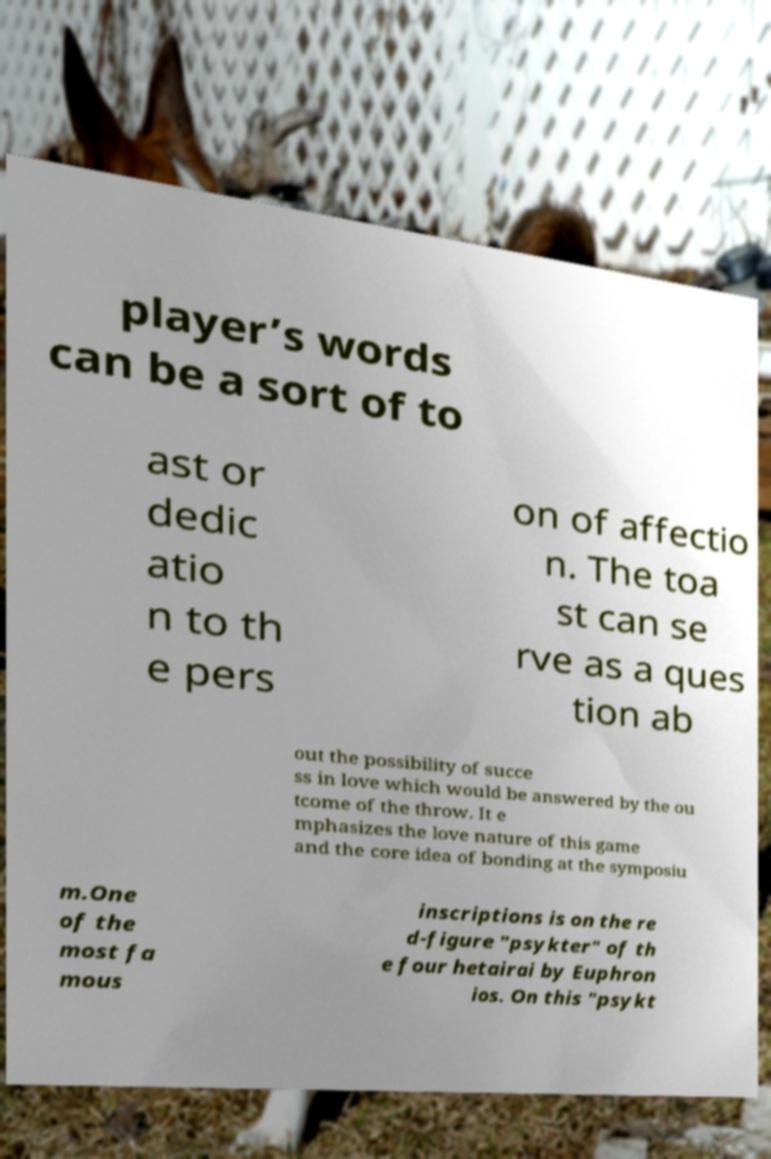Can you read and provide the text displayed in the image?This photo seems to have some interesting text. Can you extract and type it out for me? player’s words can be a sort of to ast or dedic atio n to th e pers on of affectio n. The toa st can se rve as a ques tion ab out the possibility of succe ss in love which would be answered by the ou tcome of the throw. It e mphasizes the love nature of this game and the core idea of bonding at the symposiu m.One of the most fa mous inscriptions is on the re d-figure "psykter" of th e four hetairai by Euphron ios. On this "psykt 